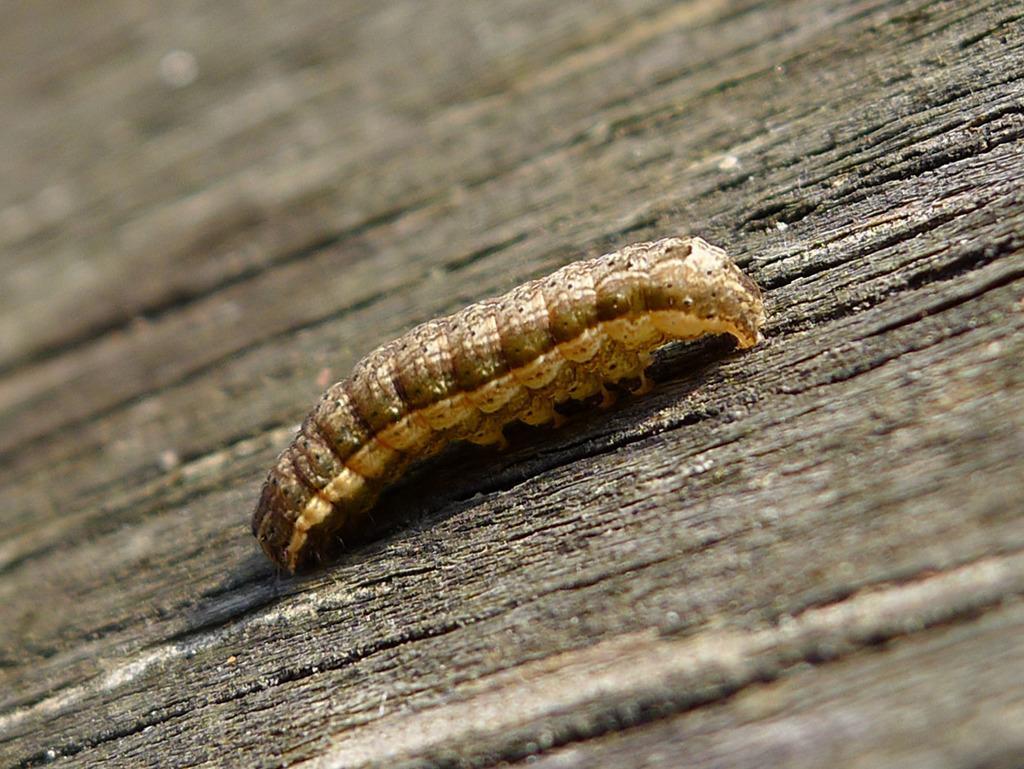Please provide a concise description of this image. In the center of the picture there is a caterpillar, on a wooden surface. 